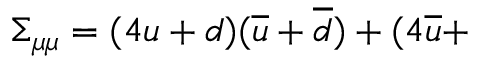Convert formula to latex. <formula><loc_0><loc_0><loc_500><loc_500>\Sigma _ { \mu \mu } = ( 4 u + d ) ( \overline { u } + \overline { d } ) + ( 4 \overline { u } +</formula> 